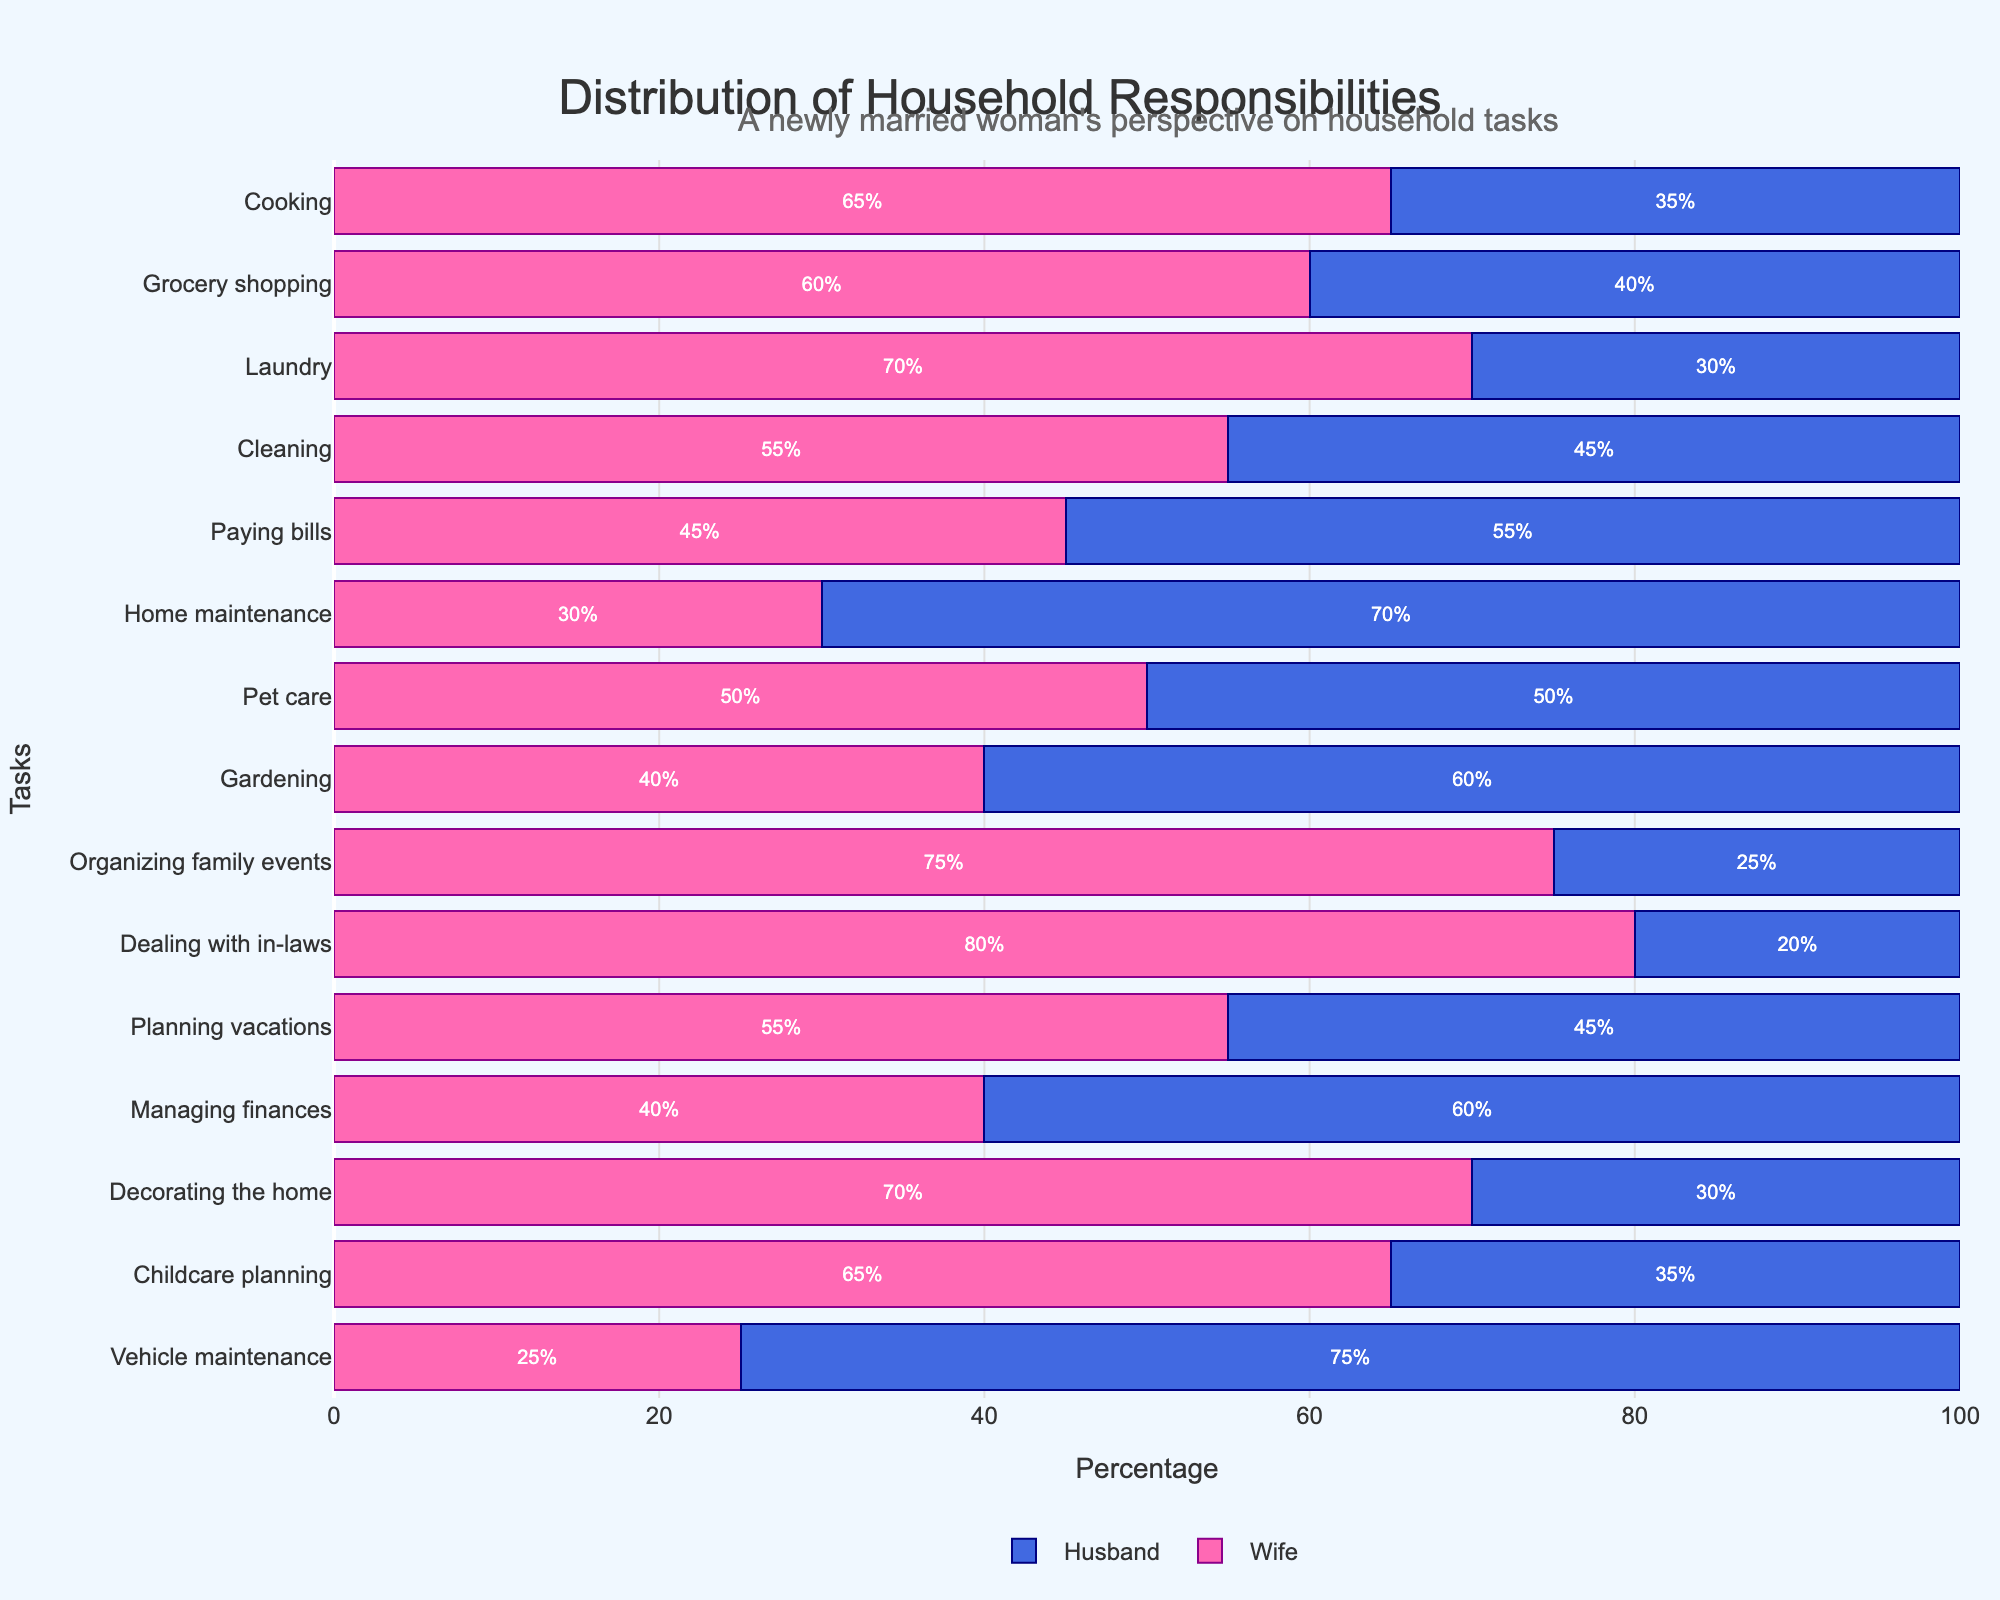Which task is shared equally between the wife and husband? The task where both percentages are equal is pet care, with both showing 50%.
Answer: Pet care Who predominantly handles dealing with in-laws, and by what percentage? For the task of dealing with in-laws, the wife handles 80%, while the husband handles 20%.
Answer: Wife (80%) What is the total percentage of tasks where the wife has a higher share? To calculate this, count the tasks where the wife's percentage is greater than the husband's and add them up: cooking (65%), grocery shopping (60%), laundry (70%), cleaning (55%), organizing family events (75%), dealing with in-laws (80%), planning vacations (55%), decorating the home (70%), childcare planning (65%).
Answer: 595% Which task has the largest percentage handled by the husband? By visually comparing the percentages, vehicle maintenance is handled 75% by the husband, which is the highest for husbands.
Answer: Vehicle maintenance (75%) Compare the percentages of home maintenance and managing finances between spouses. Which task has a higher discrepancy, and what is it? Calculate the absolute differences: home maintenance (70%-30% = 40%) and managing finances (60%-40% = 20%). The larger discrepancy is in home maintenance.
Answer: Home maintenance (40%) What is the average percentage of tasks predominantly handled by the wife (>50%)? Sum the percentages of tasks where the wife handles more than 50%: cooking (65%), grocery shopping (60%), laundry (70%), cleaning (55%), organizing family events (75%), dealing with in-laws (80%), planning vacations (55%), decorating the home (70%), childcare planning (65%). Divide by the number of such tasks (9): (65+60+70+55+75+80+55+70+65)/9 = 66.11%.
Answer: 66.11% For tasks where the wife handles 70% or more, what is the cumulative percentage of these tasks? Translate this number into an impact statement about their involvement. Identify tasks: laundry (70%), organizing family events (75%), dealing with in-laws (80%), decorating the home (70%). Sum these percentages: (70+75+80+70) = 295%. This indicates a significant involvement in these major tasks.
Answer: 295% Which tasks are shared more equally (difference of 20% or less) and what are they? List the tasks with ≤20% difference: cooking (30%), paying bills (10%), pet care (0%), planning vacations (10%). Shared tasks: pet care, paying bills, planning vacations.
Answer: Pet care, paying bills, planning vacations What's the combined percentage of tasks with a more traditional gender distribution (one partner >70%) handled by the wife and the husband, respectively? For the wife: laundry (70%), organizing family events (75%), dealing with in-laws (80%), decorating the home (70%) = 295%. For the husband: home maintenance (70%), vehicle maintenance (75%) = 145%.
Answer: Wife (295%), Husband (145%) What does the distribution indicate about financial management roles in the household? The wife handles 45% of bill payments, 40% of managing finances, and 40% of vehicle maintenance, all less than husbands’ shares. This suggests the husband takes on more financial management roles.
Answer: Husband predominant 